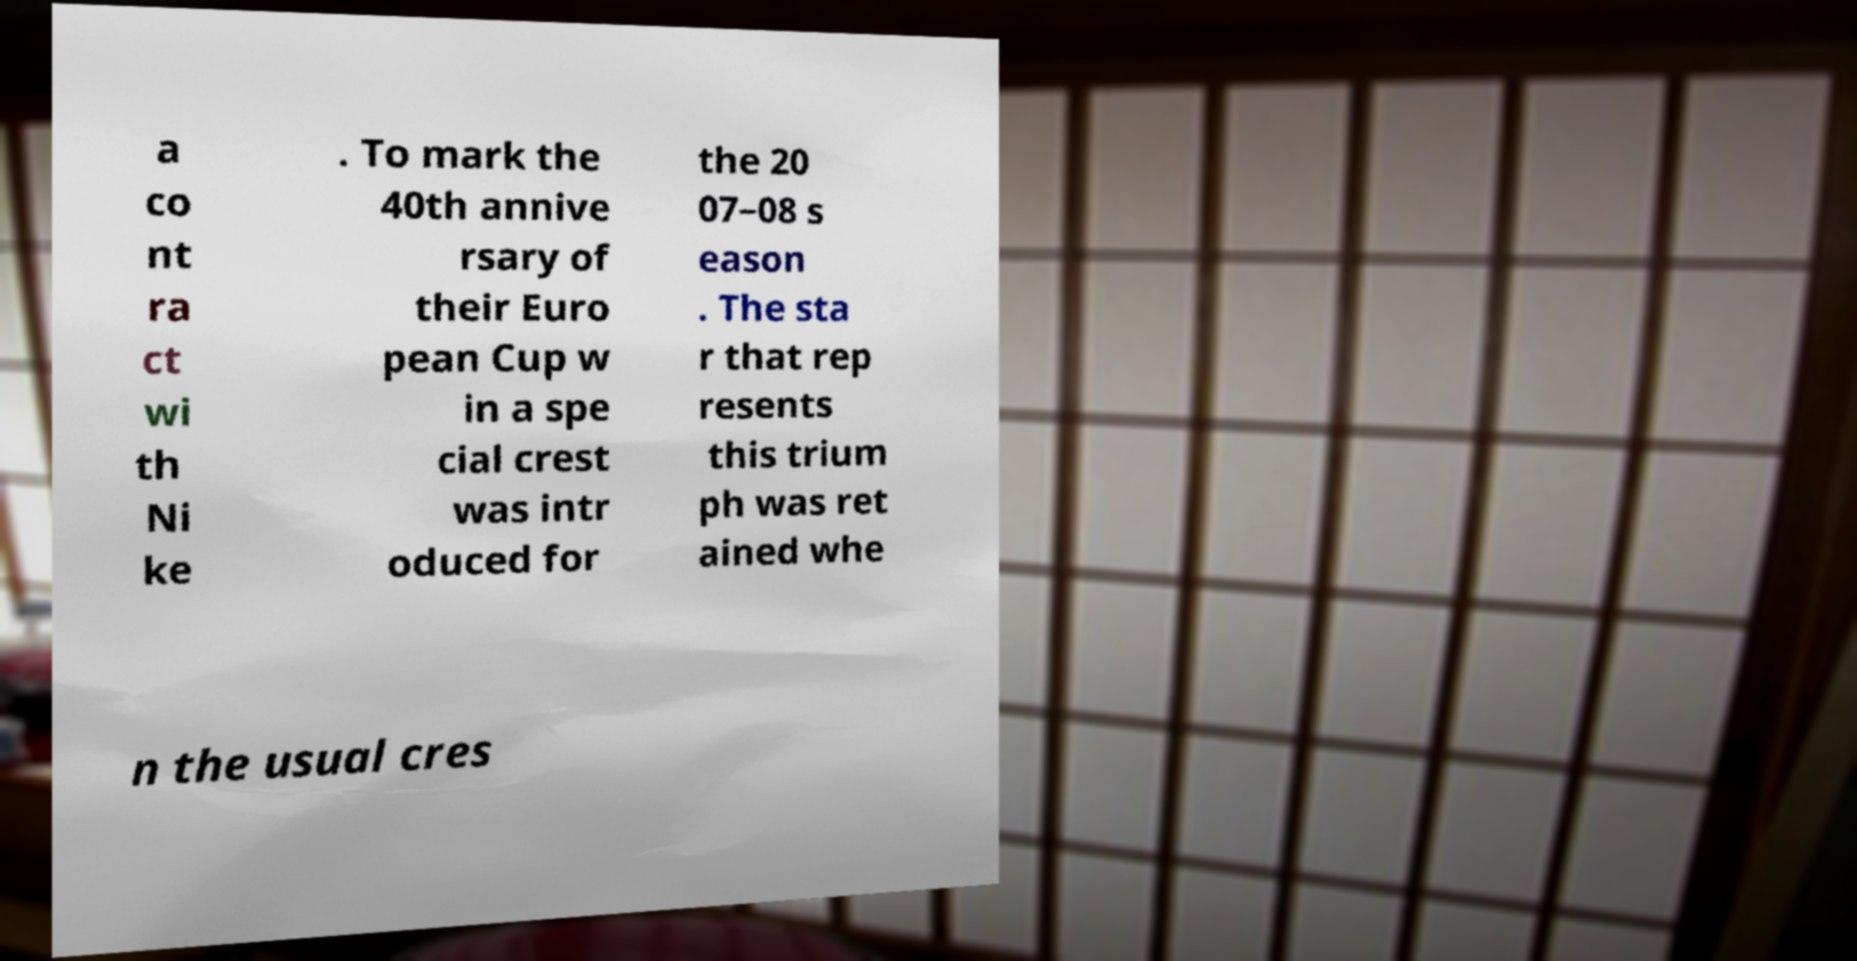Can you accurately transcribe the text from the provided image for me? a co nt ra ct wi th Ni ke . To mark the 40th annive rsary of their Euro pean Cup w in a spe cial crest was intr oduced for the 20 07–08 s eason . The sta r that rep resents this trium ph was ret ained whe n the usual cres 